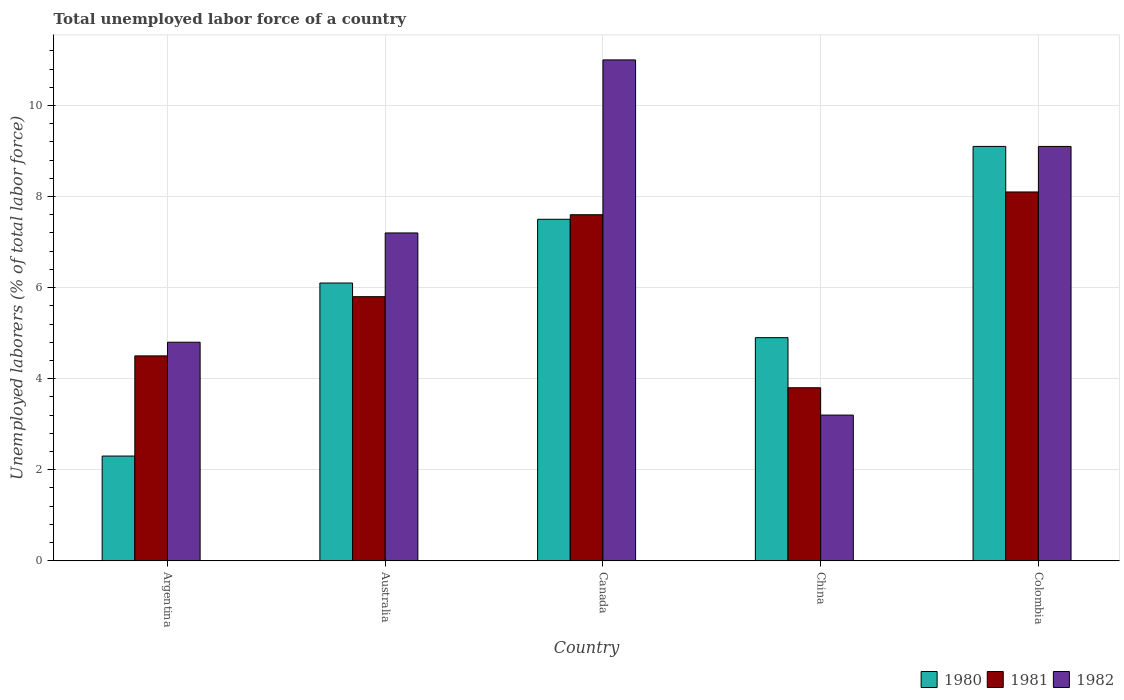How many different coloured bars are there?
Offer a very short reply. 3. How many bars are there on the 5th tick from the left?
Your response must be concise. 3. What is the label of the 1st group of bars from the left?
Your answer should be compact. Argentina. In how many cases, is the number of bars for a given country not equal to the number of legend labels?
Keep it short and to the point. 0. What is the total unemployed labor force in 1982 in Colombia?
Your response must be concise. 9.1. Across all countries, what is the maximum total unemployed labor force in 1981?
Your response must be concise. 8.1. Across all countries, what is the minimum total unemployed labor force in 1980?
Provide a short and direct response. 2.3. In which country was the total unemployed labor force in 1982 maximum?
Your answer should be very brief. Canada. In which country was the total unemployed labor force in 1980 minimum?
Provide a short and direct response. Argentina. What is the total total unemployed labor force in 1980 in the graph?
Offer a terse response. 29.9. What is the difference between the total unemployed labor force in 1982 in Australia and that in Canada?
Ensure brevity in your answer.  -3.8. What is the difference between the total unemployed labor force in 1980 in Australia and the total unemployed labor force in 1982 in Colombia?
Your answer should be very brief. -3. What is the average total unemployed labor force in 1982 per country?
Your answer should be compact. 7.06. What is the difference between the total unemployed labor force of/in 1981 and total unemployed labor force of/in 1980 in Canada?
Make the answer very short. 0.1. What is the ratio of the total unemployed labor force in 1981 in Argentina to that in Canada?
Your response must be concise. 0.59. Is the total unemployed labor force in 1981 in Argentina less than that in Australia?
Give a very brief answer. Yes. What is the difference between the highest and the second highest total unemployed labor force in 1982?
Your answer should be very brief. -1.9. What is the difference between the highest and the lowest total unemployed labor force in 1982?
Your answer should be compact. 7.8. Is the sum of the total unemployed labor force in 1981 in Argentina and China greater than the maximum total unemployed labor force in 1980 across all countries?
Offer a terse response. No. Is it the case that in every country, the sum of the total unemployed labor force in 1980 and total unemployed labor force in 1981 is greater than the total unemployed labor force in 1982?
Provide a short and direct response. Yes. How many bars are there?
Ensure brevity in your answer.  15. Are all the bars in the graph horizontal?
Offer a very short reply. No. How many countries are there in the graph?
Keep it short and to the point. 5. Are the values on the major ticks of Y-axis written in scientific E-notation?
Your response must be concise. No. How are the legend labels stacked?
Your response must be concise. Horizontal. What is the title of the graph?
Provide a short and direct response. Total unemployed labor force of a country. What is the label or title of the X-axis?
Ensure brevity in your answer.  Country. What is the label or title of the Y-axis?
Your answer should be compact. Unemployed laborers (% of total labor force). What is the Unemployed laborers (% of total labor force) of 1980 in Argentina?
Your response must be concise. 2.3. What is the Unemployed laborers (% of total labor force) of 1981 in Argentina?
Make the answer very short. 4.5. What is the Unemployed laborers (% of total labor force) in 1982 in Argentina?
Give a very brief answer. 4.8. What is the Unemployed laborers (% of total labor force) in 1980 in Australia?
Ensure brevity in your answer.  6.1. What is the Unemployed laborers (% of total labor force) in 1981 in Australia?
Make the answer very short. 5.8. What is the Unemployed laborers (% of total labor force) in 1982 in Australia?
Give a very brief answer. 7.2. What is the Unemployed laborers (% of total labor force) of 1981 in Canada?
Make the answer very short. 7.6. What is the Unemployed laborers (% of total labor force) of 1980 in China?
Offer a very short reply. 4.9. What is the Unemployed laborers (% of total labor force) in 1981 in China?
Offer a very short reply. 3.8. What is the Unemployed laborers (% of total labor force) of 1982 in China?
Give a very brief answer. 3.2. What is the Unemployed laborers (% of total labor force) in 1980 in Colombia?
Offer a terse response. 9.1. What is the Unemployed laborers (% of total labor force) of 1981 in Colombia?
Ensure brevity in your answer.  8.1. What is the Unemployed laborers (% of total labor force) in 1982 in Colombia?
Offer a terse response. 9.1. Across all countries, what is the maximum Unemployed laborers (% of total labor force) in 1980?
Offer a terse response. 9.1. Across all countries, what is the maximum Unemployed laborers (% of total labor force) in 1981?
Your answer should be very brief. 8.1. Across all countries, what is the maximum Unemployed laborers (% of total labor force) in 1982?
Offer a terse response. 11. Across all countries, what is the minimum Unemployed laborers (% of total labor force) in 1980?
Keep it short and to the point. 2.3. Across all countries, what is the minimum Unemployed laborers (% of total labor force) in 1981?
Give a very brief answer. 3.8. Across all countries, what is the minimum Unemployed laborers (% of total labor force) of 1982?
Your answer should be very brief. 3.2. What is the total Unemployed laborers (% of total labor force) in 1980 in the graph?
Your answer should be compact. 29.9. What is the total Unemployed laborers (% of total labor force) of 1981 in the graph?
Give a very brief answer. 29.8. What is the total Unemployed laborers (% of total labor force) of 1982 in the graph?
Offer a terse response. 35.3. What is the difference between the Unemployed laborers (% of total labor force) of 1980 in Argentina and that in Australia?
Ensure brevity in your answer.  -3.8. What is the difference between the Unemployed laborers (% of total labor force) in 1982 in Argentina and that in Australia?
Offer a terse response. -2.4. What is the difference between the Unemployed laborers (% of total labor force) in 1981 in Argentina and that in Canada?
Offer a terse response. -3.1. What is the difference between the Unemployed laborers (% of total labor force) in 1982 in Argentina and that in Canada?
Provide a short and direct response. -6.2. What is the difference between the Unemployed laborers (% of total labor force) of 1981 in Argentina and that in China?
Your answer should be compact. 0.7. What is the difference between the Unemployed laborers (% of total labor force) of 1982 in Australia and that in Canada?
Offer a terse response. -3.8. What is the difference between the Unemployed laborers (% of total labor force) of 1980 in Australia and that in China?
Give a very brief answer. 1.2. What is the difference between the Unemployed laborers (% of total labor force) in 1982 in Australia and that in China?
Your response must be concise. 4. What is the difference between the Unemployed laborers (% of total labor force) in 1981 in Canada and that in China?
Keep it short and to the point. 3.8. What is the difference between the Unemployed laborers (% of total labor force) in 1982 in Canada and that in China?
Ensure brevity in your answer.  7.8. What is the difference between the Unemployed laborers (% of total labor force) in 1980 in Canada and that in Colombia?
Provide a succinct answer. -1.6. What is the difference between the Unemployed laborers (% of total labor force) in 1982 in Canada and that in Colombia?
Make the answer very short. 1.9. What is the difference between the Unemployed laborers (% of total labor force) of 1980 in China and that in Colombia?
Keep it short and to the point. -4.2. What is the difference between the Unemployed laborers (% of total labor force) of 1982 in China and that in Colombia?
Offer a terse response. -5.9. What is the difference between the Unemployed laborers (% of total labor force) in 1981 in Argentina and the Unemployed laborers (% of total labor force) in 1982 in Australia?
Your answer should be very brief. -2.7. What is the difference between the Unemployed laborers (% of total labor force) in 1981 in Argentina and the Unemployed laborers (% of total labor force) in 1982 in Canada?
Provide a succinct answer. -6.5. What is the difference between the Unemployed laborers (% of total labor force) of 1980 in Argentina and the Unemployed laborers (% of total labor force) of 1981 in China?
Offer a very short reply. -1.5. What is the difference between the Unemployed laborers (% of total labor force) in 1980 in Argentina and the Unemployed laborers (% of total labor force) in 1982 in China?
Give a very brief answer. -0.9. What is the difference between the Unemployed laborers (% of total labor force) in 1981 in Argentina and the Unemployed laborers (% of total labor force) in 1982 in China?
Provide a short and direct response. 1.3. What is the difference between the Unemployed laborers (% of total labor force) of 1980 in Argentina and the Unemployed laborers (% of total labor force) of 1981 in Colombia?
Make the answer very short. -5.8. What is the difference between the Unemployed laborers (% of total labor force) in 1980 in Argentina and the Unemployed laborers (% of total labor force) in 1982 in Colombia?
Ensure brevity in your answer.  -6.8. What is the difference between the Unemployed laborers (% of total labor force) of 1981 in Australia and the Unemployed laborers (% of total labor force) of 1982 in Canada?
Offer a terse response. -5.2. What is the difference between the Unemployed laborers (% of total labor force) of 1980 in Australia and the Unemployed laborers (% of total labor force) of 1981 in China?
Provide a short and direct response. 2.3. What is the difference between the Unemployed laborers (% of total labor force) in 1980 in Australia and the Unemployed laborers (% of total labor force) in 1982 in China?
Make the answer very short. 2.9. What is the difference between the Unemployed laborers (% of total labor force) in 1981 in Australia and the Unemployed laborers (% of total labor force) in 1982 in China?
Make the answer very short. 2.6. What is the difference between the Unemployed laborers (% of total labor force) in 1980 in Australia and the Unemployed laborers (% of total labor force) in 1981 in Colombia?
Your answer should be compact. -2. What is the difference between the Unemployed laborers (% of total labor force) in 1981 in Australia and the Unemployed laborers (% of total labor force) in 1982 in Colombia?
Offer a terse response. -3.3. What is the difference between the Unemployed laborers (% of total labor force) of 1981 in Canada and the Unemployed laborers (% of total labor force) of 1982 in China?
Your answer should be compact. 4.4. What is the difference between the Unemployed laborers (% of total labor force) in 1980 in Canada and the Unemployed laborers (% of total labor force) in 1981 in Colombia?
Your response must be concise. -0.6. What is the difference between the Unemployed laborers (% of total labor force) of 1980 in Canada and the Unemployed laborers (% of total labor force) of 1982 in Colombia?
Your answer should be very brief. -1.6. What is the difference between the Unemployed laborers (% of total labor force) in 1981 in Canada and the Unemployed laborers (% of total labor force) in 1982 in Colombia?
Your response must be concise. -1.5. What is the difference between the Unemployed laborers (% of total labor force) of 1980 in China and the Unemployed laborers (% of total labor force) of 1981 in Colombia?
Offer a very short reply. -3.2. What is the average Unemployed laborers (% of total labor force) of 1980 per country?
Offer a very short reply. 5.98. What is the average Unemployed laborers (% of total labor force) in 1981 per country?
Provide a succinct answer. 5.96. What is the average Unemployed laborers (% of total labor force) in 1982 per country?
Provide a succinct answer. 7.06. What is the difference between the Unemployed laborers (% of total labor force) in 1981 and Unemployed laborers (% of total labor force) in 1982 in Australia?
Keep it short and to the point. -1.4. What is the difference between the Unemployed laborers (% of total labor force) in 1980 and Unemployed laborers (% of total labor force) in 1981 in Canada?
Your answer should be compact. -0.1. What is the difference between the Unemployed laborers (% of total labor force) in 1980 and Unemployed laborers (% of total labor force) in 1981 in China?
Make the answer very short. 1.1. What is the difference between the Unemployed laborers (% of total labor force) of 1980 and Unemployed laborers (% of total labor force) of 1982 in Colombia?
Your response must be concise. 0. What is the ratio of the Unemployed laborers (% of total labor force) of 1980 in Argentina to that in Australia?
Offer a terse response. 0.38. What is the ratio of the Unemployed laborers (% of total labor force) of 1981 in Argentina to that in Australia?
Your answer should be very brief. 0.78. What is the ratio of the Unemployed laborers (% of total labor force) of 1980 in Argentina to that in Canada?
Offer a terse response. 0.31. What is the ratio of the Unemployed laborers (% of total labor force) of 1981 in Argentina to that in Canada?
Give a very brief answer. 0.59. What is the ratio of the Unemployed laborers (% of total labor force) in 1982 in Argentina to that in Canada?
Offer a terse response. 0.44. What is the ratio of the Unemployed laborers (% of total labor force) in 1980 in Argentina to that in China?
Provide a short and direct response. 0.47. What is the ratio of the Unemployed laborers (% of total labor force) of 1981 in Argentina to that in China?
Provide a succinct answer. 1.18. What is the ratio of the Unemployed laborers (% of total labor force) in 1982 in Argentina to that in China?
Your response must be concise. 1.5. What is the ratio of the Unemployed laborers (% of total labor force) of 1980 in Argentina to that in Colombia?
Offer a terse response. 0.25. What is the ratio of the Unemployed laborers (% of total labor force) of 1981 in Argentina to that in Colombia?
Your answer should be very brief. 0.56. What is the ratio of the Unemployed laborers (% of total labor force) of 1982 in Argentina to that in Colombia?
Your response must be concise. 0.53. What is the ratio of the Unemployed laborers (% of total labor force) of 1980 in Australia to that in Canada?
Ensure brevity in your answer.  0.81. What is the ratio of the Unemployed laborers (% of total labor force) in 1981 in Australia to that in Canada?
Give a very brief answer. 0.76. What is the ratio of the Unemployed laborers (% of total labor force) in 1982 in Australia to that in Canada?
Your answer should be very brief. 0.65. What is the ratio of the Unemployed laborers (% of total labor force) in 1980 in Australia to that in China?
Your response must be concise. 1.24. What is the ratio of the Unemployed laborers (% of total labor force) in 1981 in Australia to that in China?
Your response must be concise. 1.53. What is the ratio of the Unemployed laborers (% of total labor force) of 1982 in Australia to that in China?
Offer a very short reply. 2.25. What is the ratio of the Unemployed laborers (% of total labor force) of 1980 in Australia to that in Colombia?
Make the answer very short. 0.67. What is the ratio of the Unemployed laborers (% of total labor force) in 1981 in Australia to that in Colombia?
Provide a short and direct response. 0.72. What is the ratio of the Unemployed laborers (% of total labor force) in 1982 in Australia to that in Colombia?
Give a very brief answer. 0.79. What is the ratio of the Unemployed laborers (% of total labor force) in 1980 in Canada to that in China?
Keep it short and to the point. 1.53. What is the ratio of the Unemployed laborers (% of total labor force) in 1982 in Canada to that in China?
Provide a short and direct response. 3.44. What is the ratio of the Unemployed laborers (% of total labor force) in 1980 in Canada to that in Colombia?
Keep it short and to the point. 0.82. What is the ratio of the Unemployed laborers (% of total labor force) in 1981 in Canada to that in Colombia?
Offer a very short reply. 0.94. What is the ratio of the Unemployed laborers (% of total labor force) in 1982 in Canada to that in Colombia?
Offer a terse response. 1.21. What is the ratio of the Unemployed laborers (% of total labor force) of 1980 in China to that in Colombia?
Keep it short and to the point. 0.54. What is the ratio of the Unemployed laborers (% of total labor force) of 1981 in China to that in Colombia?
Your answer should be very brief. 0.47. What is the ratio of the Unemployed laborers (% of total labor force) of 1982 in China to that in Colombia?
Keep it short and to the point. 0.35. What is the difference between the highest and the second highest Unemployed laborers (% of total labor force) in 1980?
Make the answer very short. 1.6. What is the difference between the highest and the second highest Unemployed laborers (% of total labor force) of 1982?
Your answer should be compact. 1.9. What is the difference between the highest and the lowest Unemployed laborers (% of total labor force) of 1980?
Provide a succinct answer. 6.8. What is the difference between the highest and the lowest Unemployed laborers (% of total labor force) in 1981?
Keep it short and to the point. 4.3. 